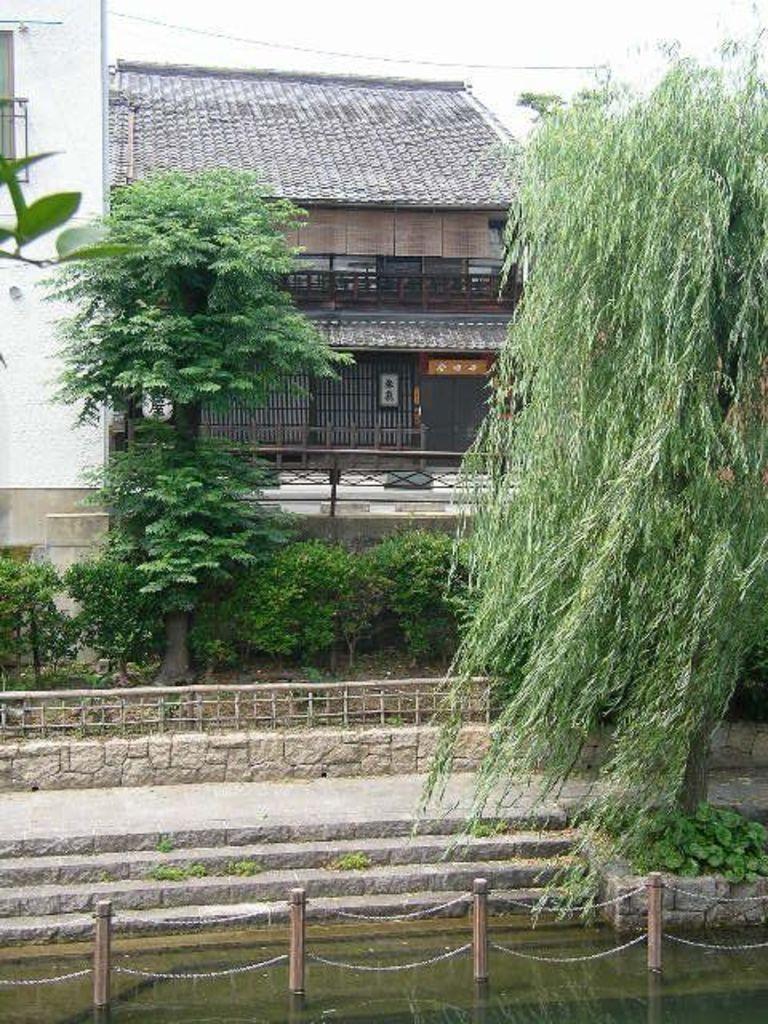Please provide a concise description of this image. In the image we can see a house, trees, plants and stairs. Here we can see water, poles and chains. We can even see fence, electric wires and white sky. 